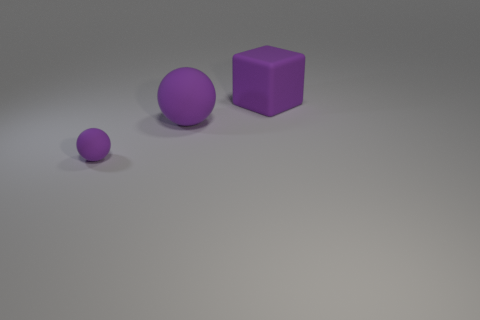What material do these objects appear to be made of, and does the surface have any particular texture? Based on the visual appearance, all objects seem to be made from a rubber-like material, exhibiting a matte texture that diffuses the light. The surfaces lack any high gloss or reflective qualities typical of metallic or plastic items. 